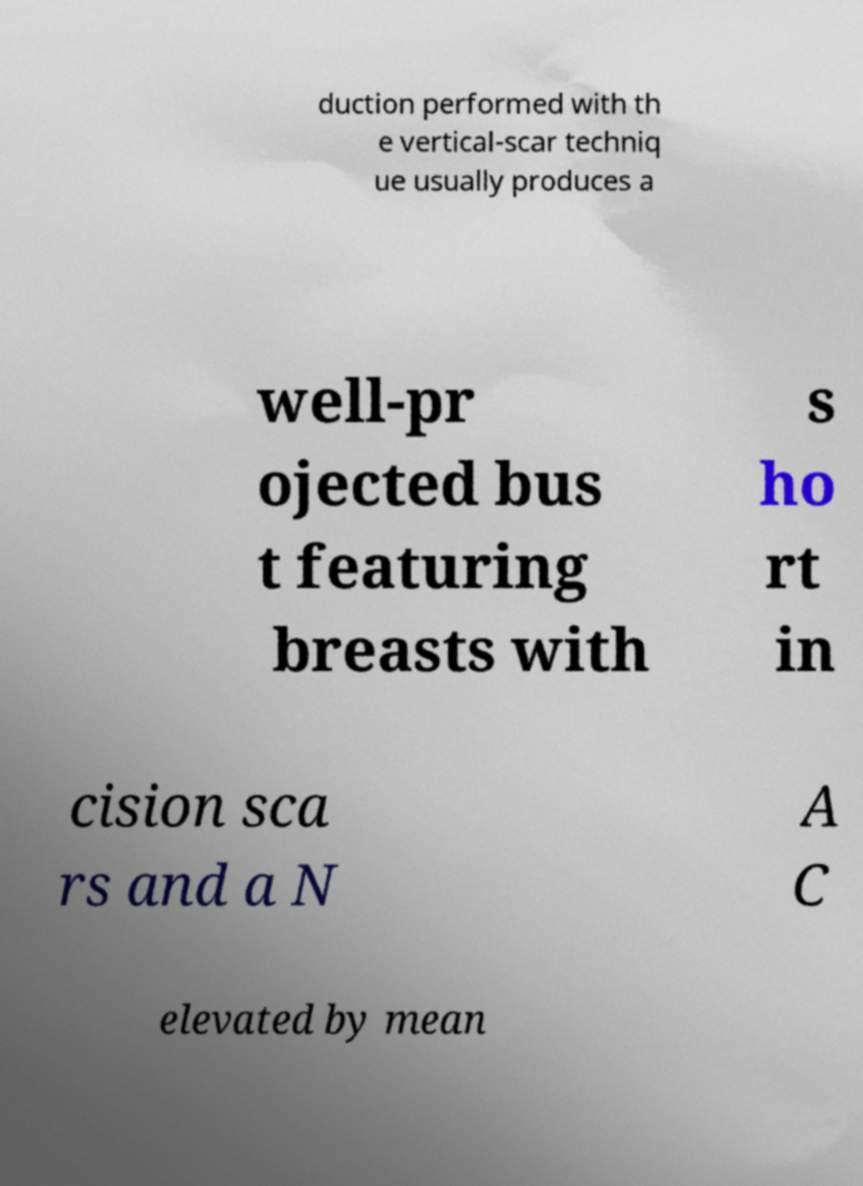I need the written content from this picture converted into text. Can you do that? duction performed with th e vertical-scar techniq ue usually produces a well-pr ojected bus t featuring breasts with s ho rt in cision sca rs and a N A C elevated by mean 